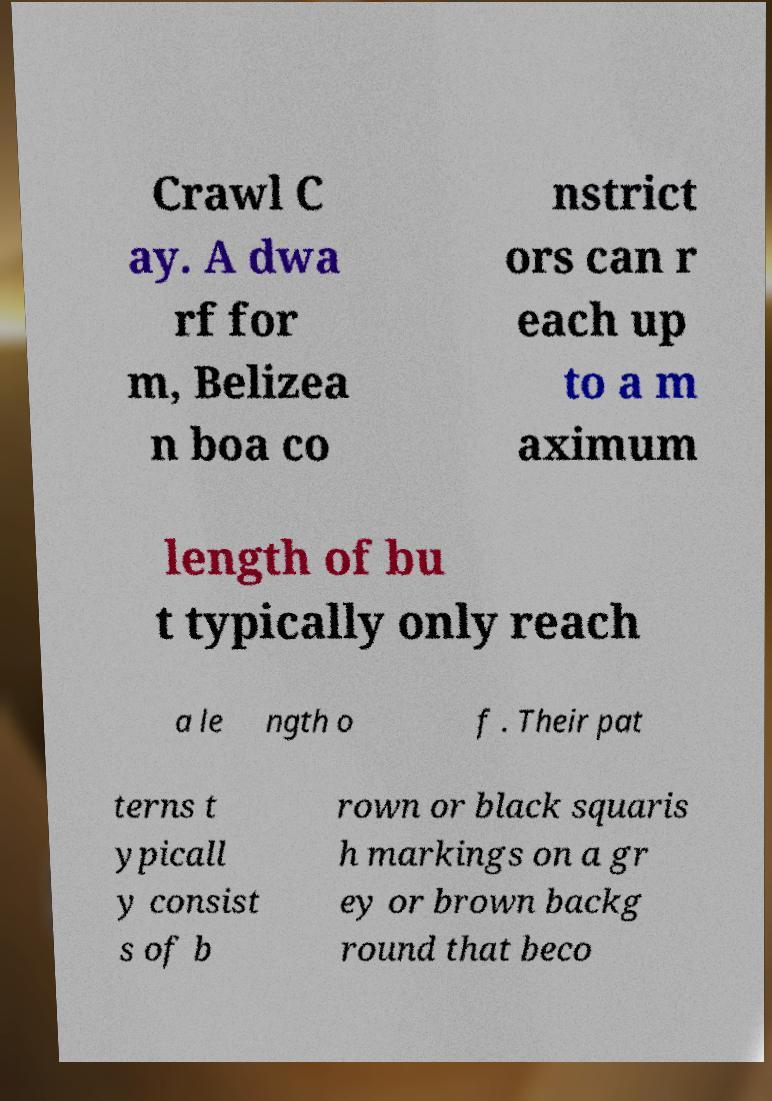Could you assist in decoding the text presented in this image and type it out clearly? Crawl C ay. A dwa rf for m, Belizea n boa co nstrict ors can r each up to a m aximum length of bu t typically only reach a le ngth o f . Their pat terns t ypicall y consist s of b rown or black squaris h markings on a gr ey or brown backg round that beco 